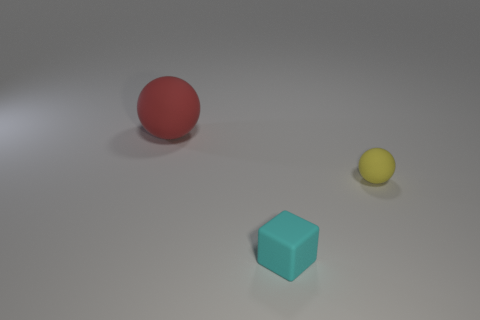Add 3 big red objects. How many objects exist? 6 Subtract all cubes. How many objects are left? 2 Subtract all red objects. Subtract all balls. How many objects are left? 0 Add 2 large rubber objects. How many large rubber objects are left? 3 Add 3 purple shiny cylinders. How many purple shiny cylinders exist? 3 Subtract 0 blue balls. How many objects are left? 3 